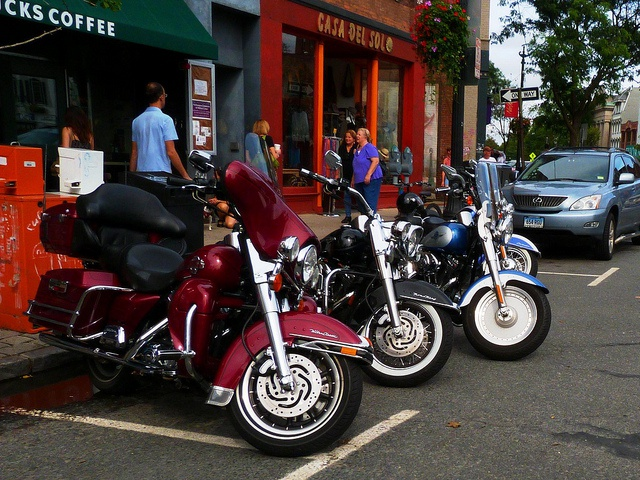Describe the objects in this image and their specific colors. I can see motorcycle in gray, black, maroon, and white tones, motorcycle in gray, black, lightgray, and darkgray tones, motorcycle in gray, black, lightgray, and darkgray tones, car in gray, black, and blue tones, and people in gray, black, darkgray, and maroon tones in this image. 